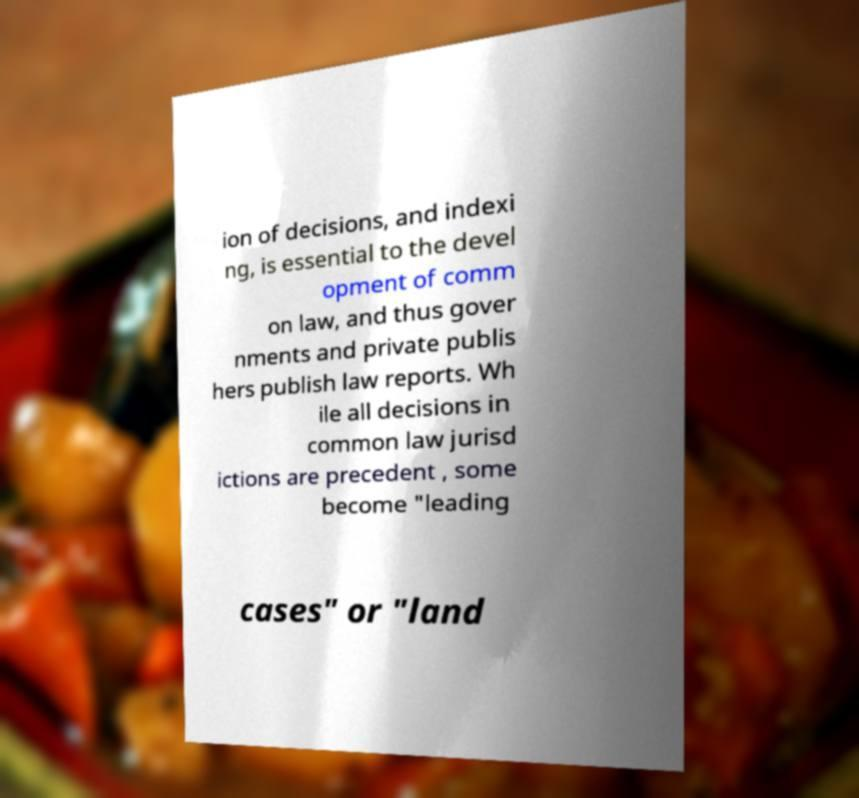Could you assist in decoding the text presented in this image and type it out clearly? ion of decisions, and indexi ng, is essential to the devel opment of comm on law, and thus gover nments and private publis hers publish law reports. Wh ile all decisions in common law jurisd ictions are precedent , some become "leading cases" or "land 